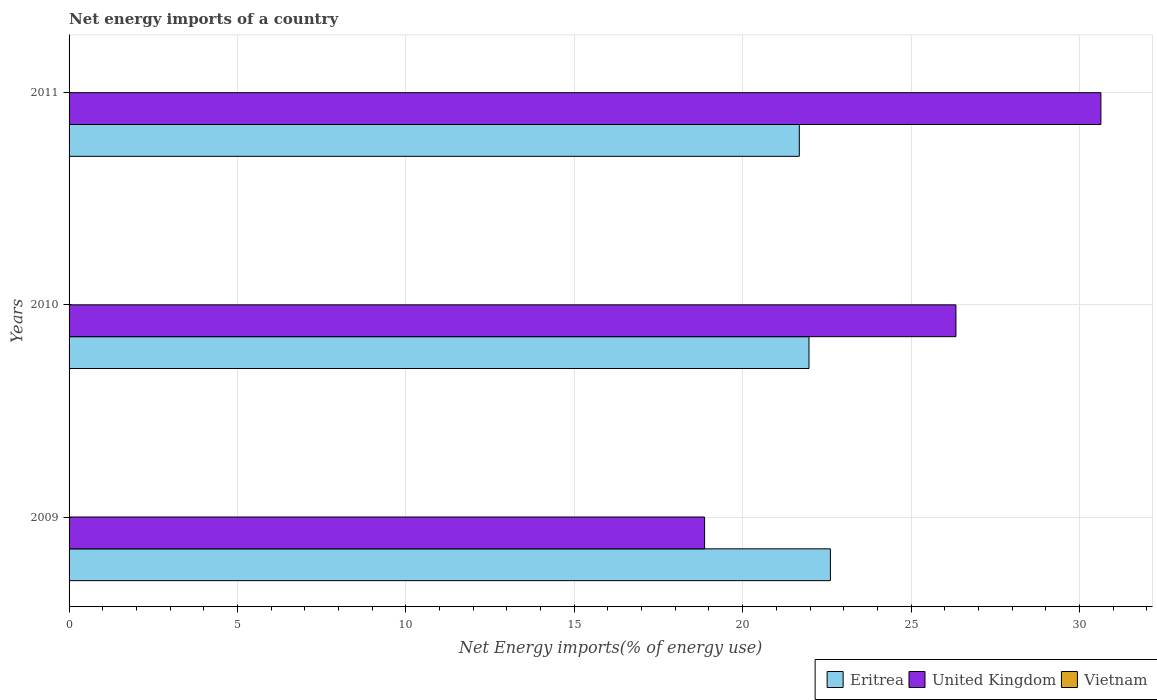How many different coloured bars are there?
Provide a succinct answer. 2. Are the number of bars per tick equal to the number of legend labels?
Your answer should be compact. No. Are the number of bars on each tick of the Y-axis equal?
Make the answer very short. Yes. How many bars are there on the 3rd tick from the bottom?
Provide a short and direct response. 2. In how many cases, is the number of bars for a given year not equal to the number of legend labels?
Offer a terse response. 3. Across all years, what is the maximum net energy imports in United Kingdom?
Offer a very short reply. 30.64. Across all years, what is the minimum net energy imports in United Kingdom?
Provide a succinct answer. 18.87. In which year was the net energy imports in Eritrea maximum?
Your response must be concise. 2009. What is the total net energy imports in Eritrea in the graph?
Offer a terse response. 66.26. What is the difference between the net energy imports in United Kingdom in 2010 and that in 2011?
Offer a terse response. -4.3. What is the difference between the net energy imports in Vietnam in 2009 and the net energy imports in Eritrea in 2011?
Offer a very short reply. -21.68. What is the average net energy imports in Eritrea per year?
Keep it short and to the point. 22.09. In the year 2010, what is the difference between the net energy imports in United Kingdom and net energy imports in Eritrea?
Make the answer very short. 4.36. What is the ratio of the net energy imports in United Kingdom in 2009 to that in 2011?
Provide a short and direct response. 0.62. Is the difference between the net energy imports in United Kingdom in 2009 and 2010 greater than the difference between the net energy imports in Eritrea in 2009 and 2010?
Offer a terse response. No. What is the difference between the highest and the second highest net energy imports in United Kingdom?
Offer a terse response. 4.3. What is the difference between the highest and the lowest net energy imports in Eritrea?
Offer a terse response. 0.92. Is the sum of the net energy imports in Eritrea in 2009 and 2011 greater than the maximum net energy imports in Vietnam across all years?
Give a very brief answer. Yes. Is it the case that in every year, the sum of the net energy imports in United Kingdom and net energy imports in Vietnam is greater than the net energy imports in Eritrea?
Give a very brief answer. No. Are all the bars in the graph horizontal?
Offer a very short reply. Yes. How many years are there in the graph?
Your answer should be very brief. 3. Are the values on the major ticks of X-axis written in scientific E-notation?
Ensure brevity in your answer.  No. Where does the legend appear in the graph?
Offer a very short reply. Bottom right. How are the legend labels stacked?
Your response must be concise. Horizontal. What is the title of the graph?
Your answer should be very brief. Net energy imports of a country. What is the label or title of the X-axis?
Give a very brief answer. Net Energy imports(% of energy use). What is the Net Energy imports(% of energy use) of Eritrea in 2009?
Offer a terse response. 22.61. What is the Net Energy imports(% of energy use) in United Kingdom in 2009?
Make the answer very short. 18.87. What is the Net Energy imports(% of energy use) of Eritrea in 2010?
Give a very brief answer. 21.97. What is the Net Energy imports(% of energy use) of United Kingdom in 2010?
Keep it short and to the point. 26.33. What is the Net Energy imports(% of energy use) of Eritrea in 2011?
Your response must be concise. 21.68. What is the Net Energy imports(% of energy use) in United Kingdom in 2011?
Keep it short and to the point. 30.64. What is the Net Energy imports(% of energy use) of Vietnam in 2011?
Make the answer very short. 0. Across all years, what is the maximum Net Energy imports(% of energy use) of Eritrea?
Keep it short and to the point. 22.61. Across all years, what is the maximum Net Energy imports(% of energy use) in United Kingdom?
Your answer should be very brief. 30.64. Across all years, what is the minimum Net Energy imports(% of energy use) in Eritrea?
Your answer should be very brief. 21.68. Across all years, what is the minimum Net Energy imports(% of energy use) of United Kingdom?
Make the answer very short. 18.87. What is the total Net Energy imports(% of energy use) in Eritrea in the graph?
Provide a short and direct response. 66.26. What is the total Net Energy imports(% of energy use) in United Kingdom in the graph?
Your answer should be very brief. 75.84. What is the difference between the Net Energy imports(% of energy use) of Eritrea in 2009 and that in 2010?
Make the answer very short. 0.64. What is the difference between the Net Energy imports(% of energy use) of United Kingdom in 2009 and that in 2010?
Make the answer very short. -7.46. What is the difference between the Net Energy imports(% of energy use) of Eritrea in 2009 and that in 2011?
Offer a terse response. 0.92. What is the difference between the Net Energy imports(% of energy use) in United Kingdom in 2009 and that in 2011?
Give a very brief answer. -11.77. What is the difference between the Net Energy imports(% of energy use) in Eritrea in 2010 and that in 2011?
Your answer should be very brief. 0.29. What is the difference between the Net Energy imports(% of energy use) in United Kingdom in 2010 and that in 2011?
Provide a short and direct response. -4.3. What is the difference between the Net Energy imports(% of energy use) of Eritrea in 2009 and the Net Energy imports(% of energy use) of United Kingdom in 2010?
Make the answer very short. -3.73. What is the difference between the Net Energy imports(% of energy use) of Eritrea in 2009 and the Net Energy imports(% of energy use) of United Kingdom in 2011?
Your answer should be very brief. -8.03. What is the difference between the Net Energy imports(% of energy use) in Eritrea in 2010 and the Net Energy imports(% of energy use) in United Kingdom in 2011?
Provide a succinct answer. -8.67. What is the average Net Energy imports(% of energy use) of Eritrea per year?
Make the answer very short. 22.09. What is the average Net Energy imports(% of energy use) in United Kingdom per year?
Ensure brevity in your answer.  25.28. In the year 2009, what is the difference between the Net Energy imports(% of energy use) in Eritrea and Net Energy imports(% of energy use) in United Kingdom?
Provide a succinct answer. 3.74. In the year 2010, what is the difference between the Net Energy imports(% of energy use) in Eritrea and Net Energy imports(% of energy use) in United Kingdom?
Give a very brief answer. -4.36. In the year 2011, what is the difference between the Net Energy imports(% of energy use) in Eritrea and Net Energy imports(% of energy use) in United Kingdom?
Your answer should be very brief. -8.95. What is the ratio of the Net Energy imports(% of energy use) of Eritrea in 2009 to that in 2010?
Offer a terse response. 1.03. What is the ratio of the Net Energy imports(% of energy use) in United Kingdom in 2009 to that in 2010?
Keep it short and to the point. 0.72. What is the ratio of the Net Energy imports(% of energy use) of Eritrea in 2009 to that in 2011?
Your answer should be compact. 1.04. What is the ratio of the Net Energy imports(% of energy use) of United Kingdom in 2009 to that in 2011?
Your response must be concise. 0.62. What is the ratio of the Net Energy imports(% of energy use) in Eritrea in 2010 to that in 2011?
Ensure brevity in your answer.  1.01. What is the ratio of the Net Energy imports(% of energy use) of United Kingdom in 2010 to that in 2011?
Your answer should be very brief. 0.86. What is the difference between the highest and the second highest Net Energy imports(% of energy use) in Eritrea?
Provide a short and direct response. 0.64. What is the difference between the highest and the second highest Net Energy imports(% of energy use) in United Kingdom?
Make the answer very short. 4.3. What is the difference between the highest and the lowest Net Energy imports(% of energy use) of Eritrea?
Make the answer very short. 0.92. What is the difference between the highest and the lowest Net Energy imports(% of energy use) of United Kingdom?
Offer a very short reply. 11.77. 